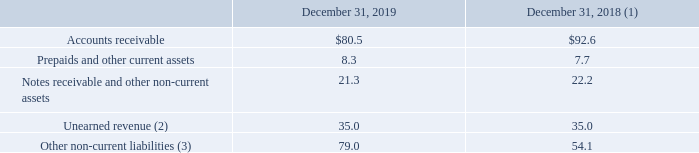AMERICAN TOWER CORPORATION AND SUBSIDIARIES NOTES TO CONSOLIDATED FINANCIAL STATEMENTS (Tabular amounts in millions, unless otherwise disclosed)
Information about receivables, contract assets and contract liabilities from contracts with tenants is as follows:
(1) Prior-period amounts adjusted with the adoption of the new lease accounting guidance, as applicable.
(2) Excludes $56.7 million and $55.0 million of capital contributions related to DAS networks as of December 31, 2019 and 2018, respectively.
(3) Excludes $300.2 million and $313.6 million of capital contributions related to DAS networks as of December 31, 2019 and 2018, respectively.
The Company records unearned revenue when payments are received from tenants in advance of the completion of the Company’s performance obligations. Long-term unearned revenue is included in Other non-current liabilities. During the year ended December 31, 2019, the Company recognized $62.2 million of revenue that was included in the Unearned revenue balance as of December 31, 2018. During the year ended December 31, 2018, the Company recognized $44.4 million of revenue that was included in the Unearned revenue balance as of January 1, 2018. The Company also recognized revenues of $59.2 million and $55.4 million during the years ended December 31, 2019 and December 31, 2018, respectively, for capital contributions related to DAS networks. There was $0.4 million of revenue recognized from Other non-current liabilities during each of the years ended December 31, 2019 and 2018. $59.2 million and $55.4 million during the years ended December 31, 2019 and December 31, 2018, respectively, for capital contributions related to DAS networks. There was $0.4 million of revenue recognized from Other non-current liabilities during each of the years ended December 31, 2019 and 2018.
$59.2 million and $55.4 million during the years ended December 31, 2019 and December 31, 2018, respectively, for capital
contributions related to DAS networks. There was $0.4 million of revenue recognized from Other non-current liabilities during
each of the years ended December 31, 2019 and 2018.
What does unearned revenue exclude? $56.7 million and $55.0 million of capital contributions related to das networks as of december 31, 2019 and 2018, respectively. What does Other non-current liabilities exclude? Excludes $300.2 million and $313.6 million of capital contributions related to das networks as of december 31, 2019 and 2018, respectively. What was Prepaids and other current assets in 2019?
Answer scale should be: million. 8.3. What was the change in Other non-current liabilities between 2018 and 2019?
Answer scale should be: million. 79.0-54.1
Answer: 24.9. What was the change in Prepaids and other current assets between 2018 and 2019?
Answer scale should be: million. 8.3-7.7
Answer: 0.6. What was the percentage change in Accounts receivable between 2018 and 2019?
Answer scale should be: percent. ($80.5-$92.6)/$92.6
Answer: -13.07. 